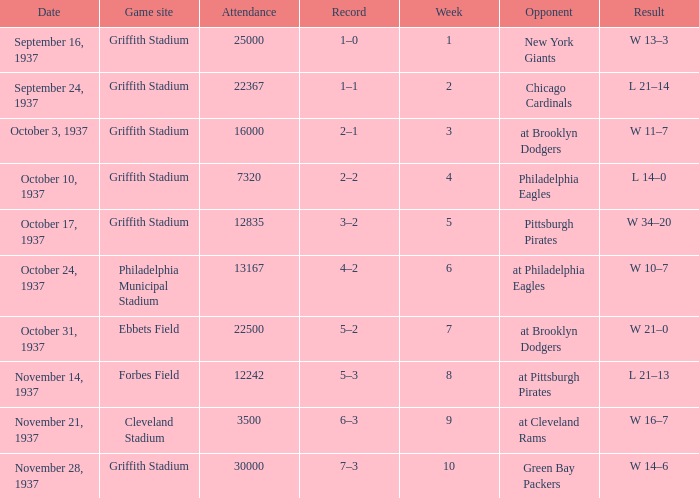On October 17, 1937 what was maximum number or attendants. 12835.0. 